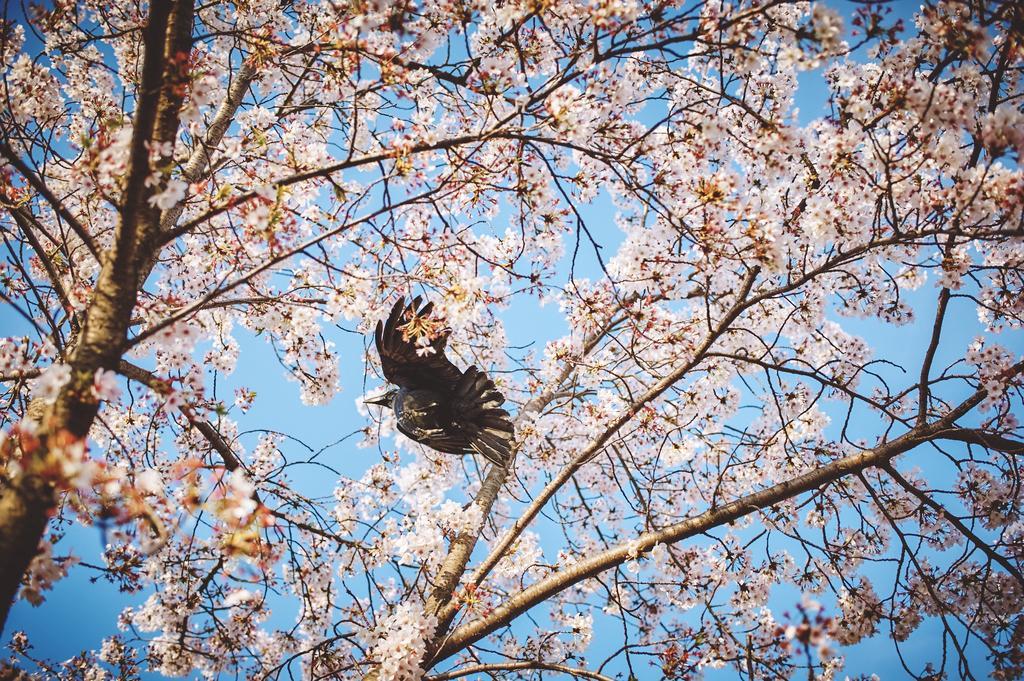Could you give a brief overview of what you see in this image? In the image there is a bird standing on a tree with pink flowers and above its sky. 